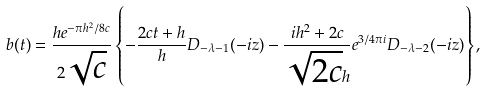<formula> <loc_0><loc_0><loc_500><loc_500>b ( t ) = \frac { h e ^ { - \pi h ^ { 2 } / 8 c } } { 2 \sqrt { c } } \left \{ - \frac { 2 c t + h } { h } D _ { - \lambda - 1 } ( - i z ) - \frac { i h ^ { 2 } + 2 c } { \sqrt { 2 c } h } e ^ { 3 / 4 \pi i } D _ { - \lambda - 2 } ( - i z ) \right \} ,</formula> 